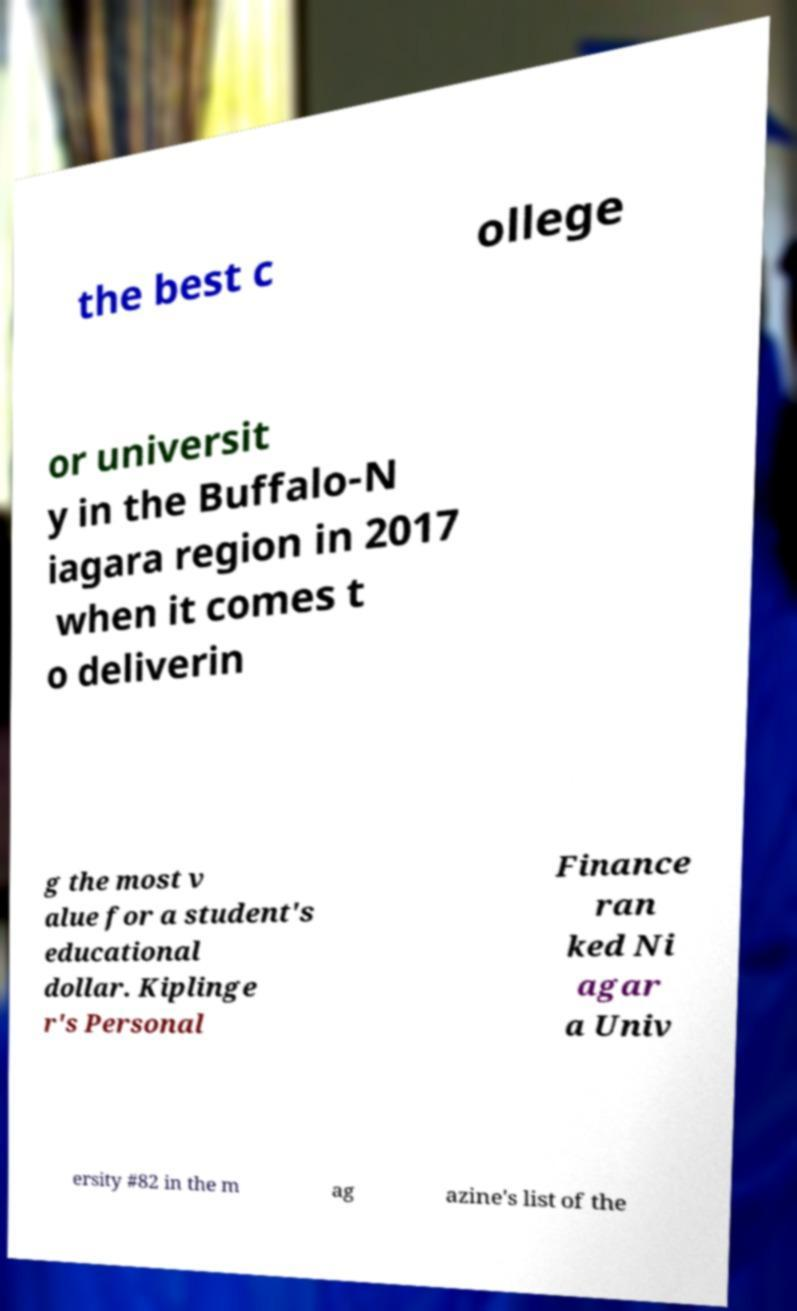Could you extract and type out the text from this image? the best c ollege or universit y in the Buffalo-N iagara region in 2017 when it comes t o deliverin g the most v alue for a student's educational dollar. Kiplinge r's Personal Finance ran ked Ni agar a Univ ersity #82 in the m ag azine's list of the 